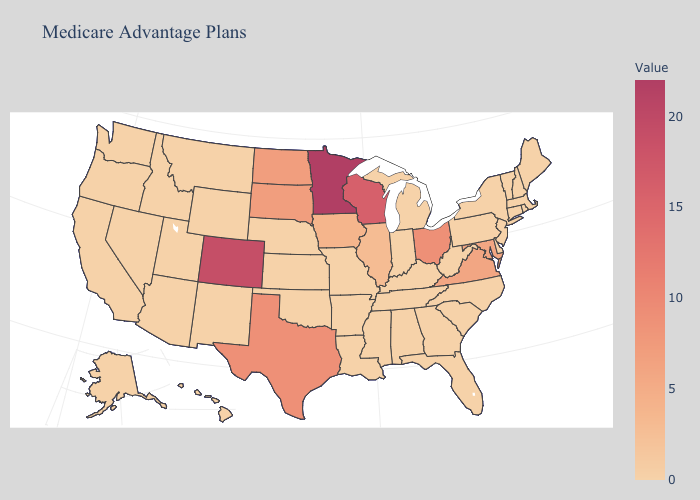Among the states that border Arizona , which have the highest value?
Be succinct. Colorado. Among the states that border Delaware , which have the highest value?
Be succinct. Maryland. Does Colorado have the lowest value in the West?
Be succinct. No. 